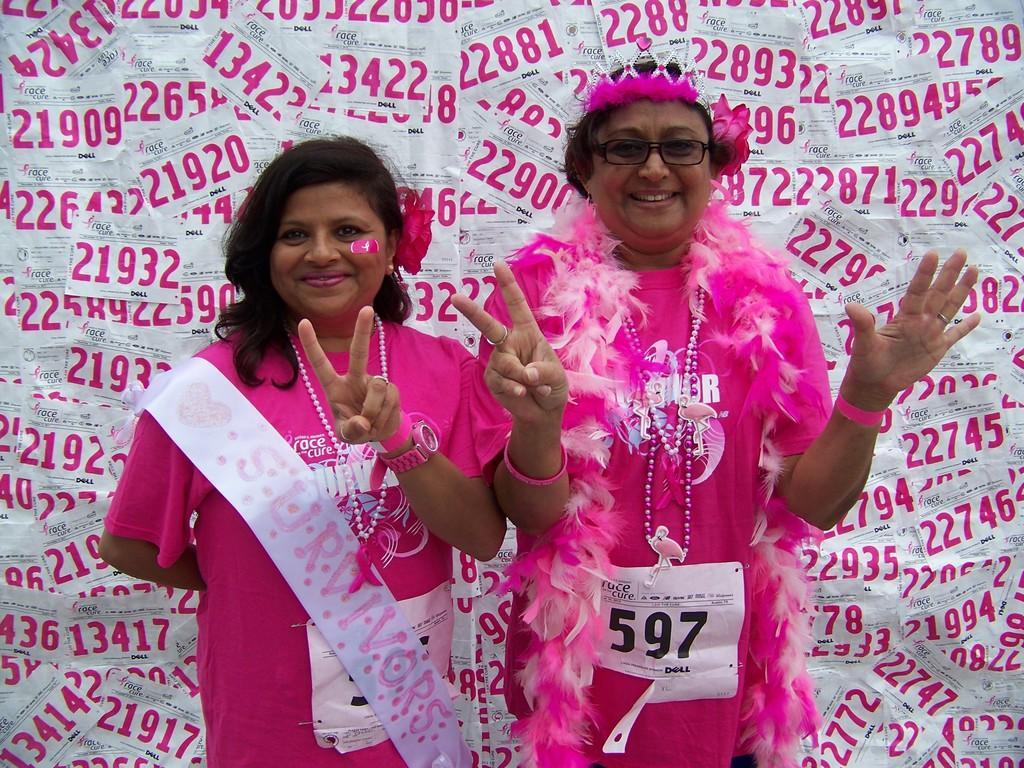Can you describe this image briefly? In this picture i can see two women are standing together and smiling. These women are wearing pink color dress and necklaces. The woman on the right side is wearing spectacles and crown. In the background i can see papers on which i can see numbers. 